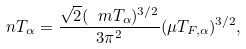<formula> <loc_0><loc_0><loc_500><loc_500>\ n T _ { \alpha } = \frac { \sqrt { 2 } ( \ m T _ { \alpha } ) ^ { 3 / 2 } } { 3 \pi ^ { 2 } } ( \mu T _ { F , \alpha } ) ^ { 3 / 2 } ,</formula> 